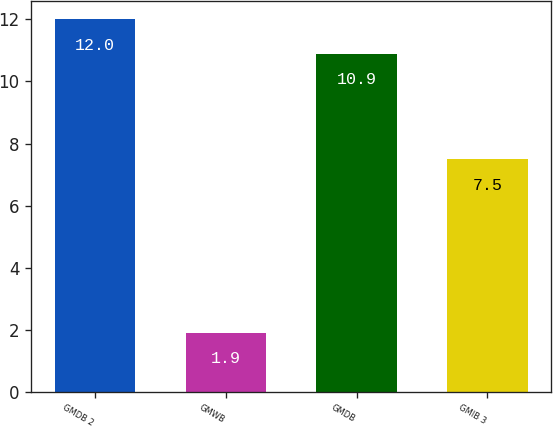Convert chart. <chart><loc_0><loc_0><loc_500><loc_500><bar_chart><fcel>GMDB 2<fcel>GMWB<fcel>GMDB<fcel>GMIB 3<nl><fcel>12<fcel>1.9<fcel>10.9<fcel>7.5<nl></chart> 